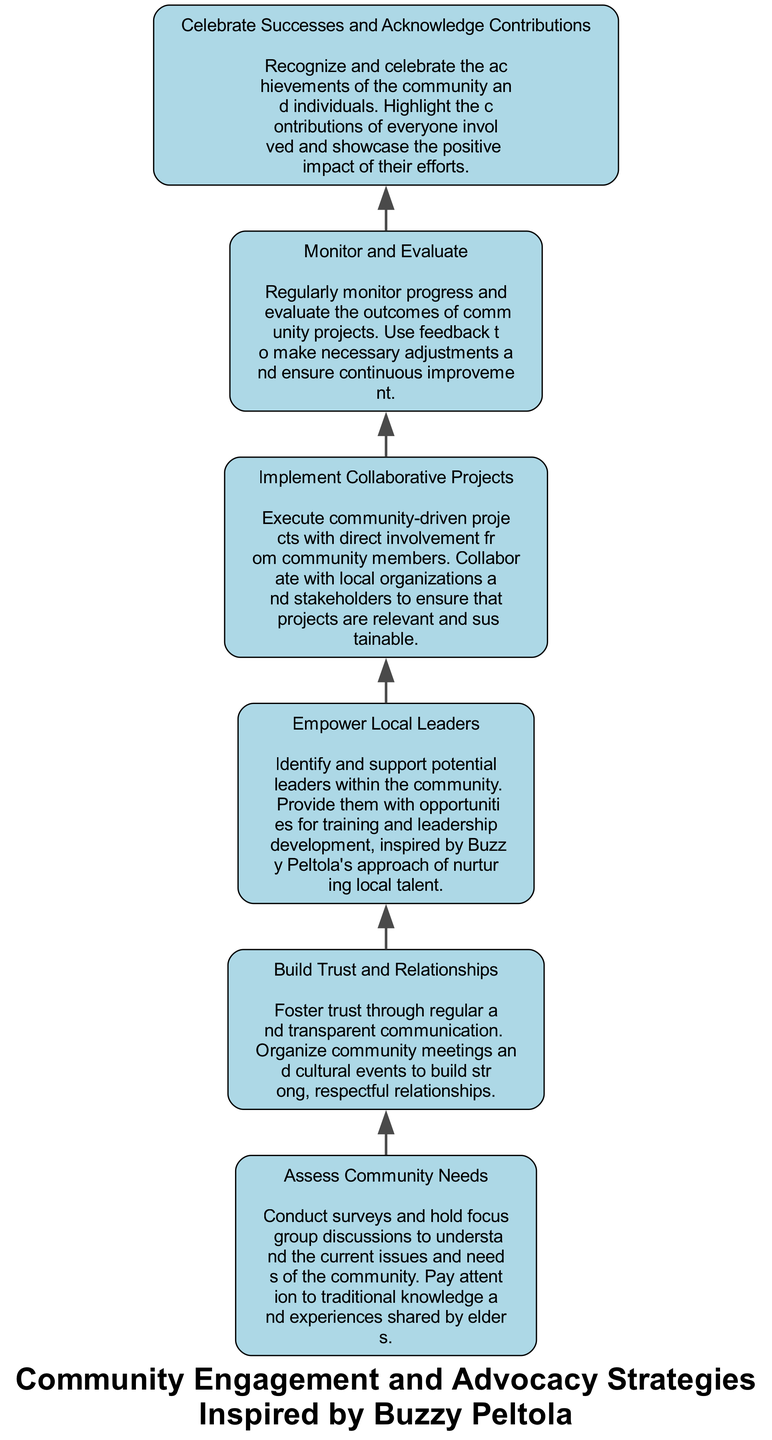What is the first step in the flow chart? The first step, according to the flow chart, is "Assess Community Needs". This is because the flow starts at the bottom, where this node is positioned, indicating it is the initial action taken in the process.
Answer: Assess Community Needs How many nodes are in the diagram? There are six nodes listed in the flow chart. Each of these nodes represents a specific step in the community engagement and advocacy strategies, indicating a sequence of actions.
Answer: 6 What does the second node focus on? The second node is titled "Build Trust and Relationships". This focuses on the importance of fostering trust through communication and community activities, as shown directly in that node's description.
Answer: Build Trust and Relationships Which node comes after "Empower Local Leaders"? The node that follows "Empower Local Leaders" is "Implement Collaborative Projects". This path can be traced directly upward from the corresponding node.
Answer: Implement Collaborative Projects What is the purpose of "Monitor and Evaluate"? The purpose of "Monitor and Evaluate" is to regularly assess the progress and outcomes of community projects, allowing for necessary adjustments based on feedback received. This is articulated in the description of that node.
Answer: Regularly monitor progress What is the relationship between "Celebrate Successes and Acknowledge Contributions" and "Monitor and Evaluate"? The relationship is that "Celebrate Successes and Acknowledge Contributions" comes after "Monitor and Evaluate" in the flow chart. This indicates that acknowledging contributions occurs after assessment, showcasing a sequential process of evaluation followed by recognition.
Answer: Sequential process Which action emphasizes on recognizing community achievements? The action that emphasizes recognizing community achievements is "Celebrate Successes and Acknowledge Contributions". This directly points to the importance of acknowledging contributions highlighted in its title and description.
Answer: Celebrate Successes and Acknowledge Contributions How many edges are connecting the nodes? There are five edges in total connecting the nodes in the diagram. Each edge represents the directional relationship or flow from one step to another throughout the process depicted.
Answer: 5 What is the title of the flow chart? The title of the flow chart is "Community Engagement and Advocacy Strategies Inspired by Buzzy Peltola". This title summarizes the overall theme of the flow chart and its source of inspiration.
Answer: Community Engagement and Advocacy Strategies Inspired by Buzzy Peltola 